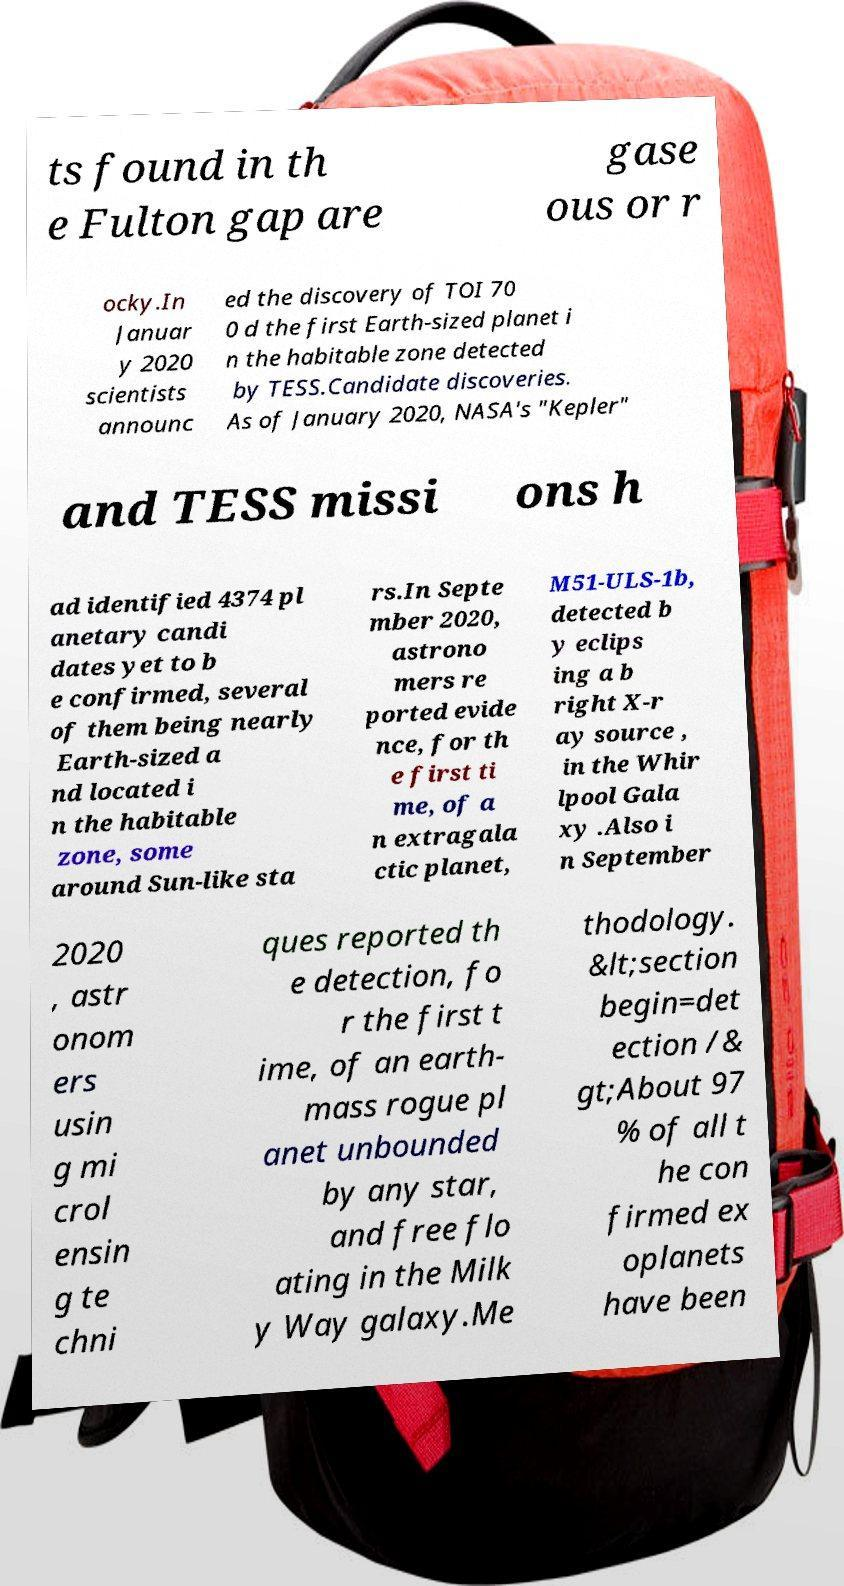Could you assist in decoding the text presented in this image and type it out clearly? ts found in th e Fulton gap are gase ous or r ocky.In Januar y 2020 scientists announc ed the discovery of TOI 70 0 d the first Earth-sized planet i n the habitable zone detected by TESS.Candidate discoveries. As of January 2020, NASA's "Kepler" and TESS missi ons h ad identified 4374 pl anetary candi dates yet to b e confirmed, several of them being nearly Earth-sized a nd located i n the habitable zone, some around Sun-like sta rs.In Septe mber 2020, astrono mers re ported evide nce, for th e first ti me, of a n extragala ctic planet, M51-ULS-1b, detected b y eclips ing a b right X-r ay source , in the Whir lpool Gala xy .Also i n September 2020 , astr onom ers usin g mi crol ensin g te chni ques reported th e detection, fo r the first t ime, of an earth- mass rogue pl anet unbounded by any star, and free flo ating in the Milk y Way galaxy.Me thodology. &lt;section begin=det ection /& gt;About 97 % of all t he con firmed ex oplanets have been 